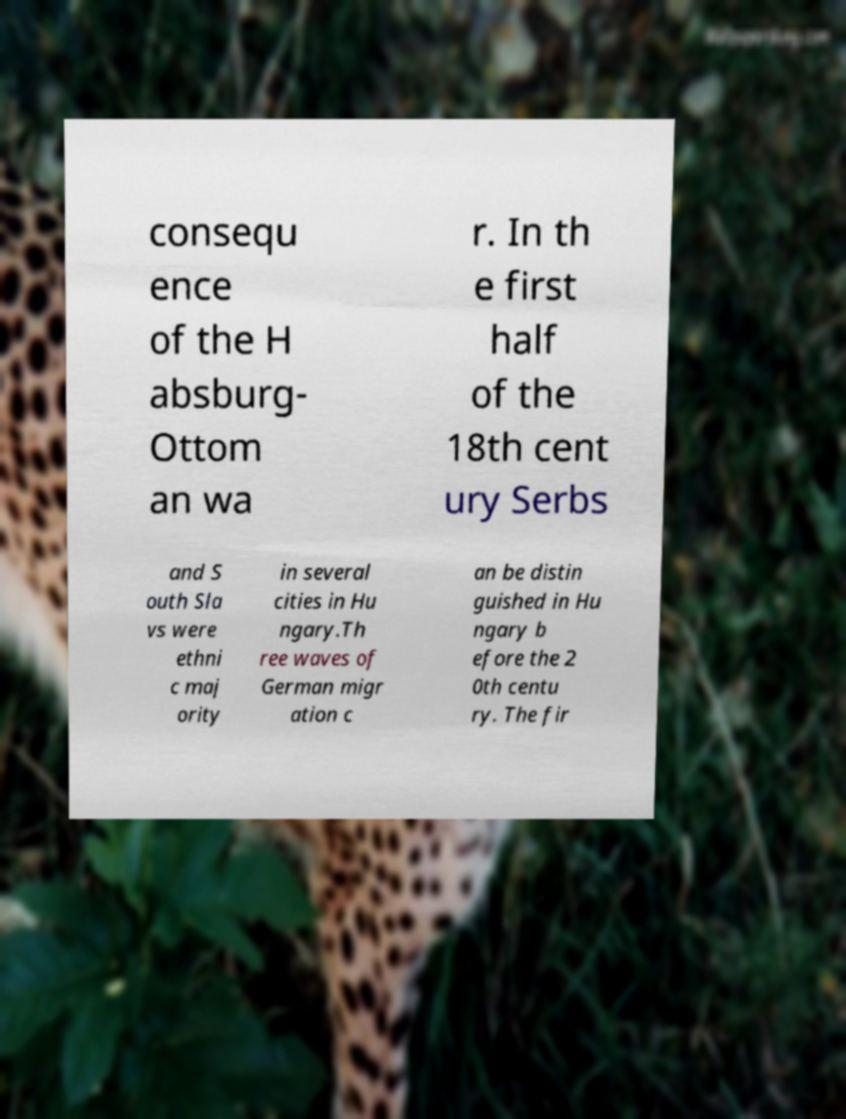Please identify and transcribe the text found in this image. consequ ence of the H absburg- Ottom an wa r. In th e first half of the 18th cent ury Serbs and S outh Sla vs were ethni c maj ority in several cities in Hu ngary.Th ree waves of German migr ation c an be distin guished in Hu ngary b efore the 2 0th centu ry. The fir 